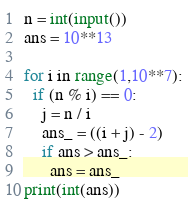<code> <loc_0><loc_0><loc_500><loc_500><_Python_>n = int(input())
ans = 10**13    

for i in range(1,10**7):
  if (n % i) == 0: 
    j = n / i
    ans_ = ((i + j) - 2)
    if ans > ans_:
      ans = ans_
print(int(ans))

</code> 